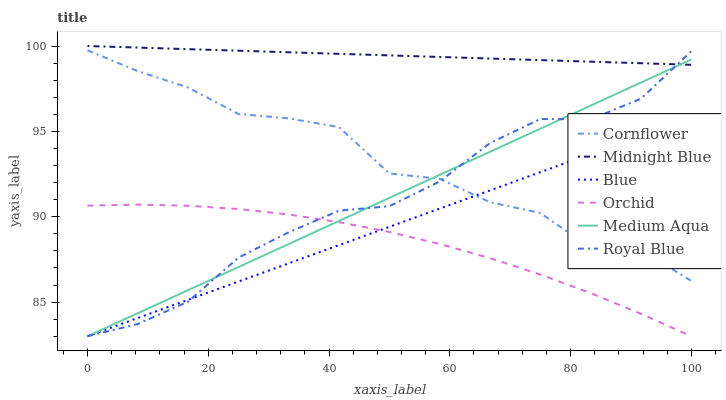Does Orchid have the minimum area under the curve?
Answer yes or no. Yes. Does Midnight Blue have the maximum area under the curve?
Answer yes or no. Yes. Does Cornflower have the minimum area under the curve?
Answer yes or no. No. Does Cornflower have the maximum area under the curve?
Answer yes or no. No. Is Midnight Blue the smoothest?
Answer yes or no. Yes. Is Cornflower the roughest?
Answer yes or no. Yes. Is Cornflower the smoothest?
Answer yes or no. No. Is Midnight Blue the roughest?
Answer yes or no. No. Does Blue have the lowest value?
Answer yes or no. Yes. Does Cornflower have the lowest value?
Answer yes or no. No. Does Midnight Blue have the highest value?
Answer yes or no. Yes. Does Cornflower have the highest value?
Answer yes or no. No. Is Orchid less than Midnight Blue?
Answer yes or no. Yes. Is Cornflower greater than Orchid?
Answer yes or no. Yes. Does Midnight Blue intersect Medium Aqua?
Answer yes or no. Yes. Is Midnight Blue less than Medium Aqua?
Answer yes or no. No. Is Midnight Blue greater than Medium Aqua?
Answer yes or no. No. Does Orchid intersect Midnight Blue?
Answer yes or no. No. 